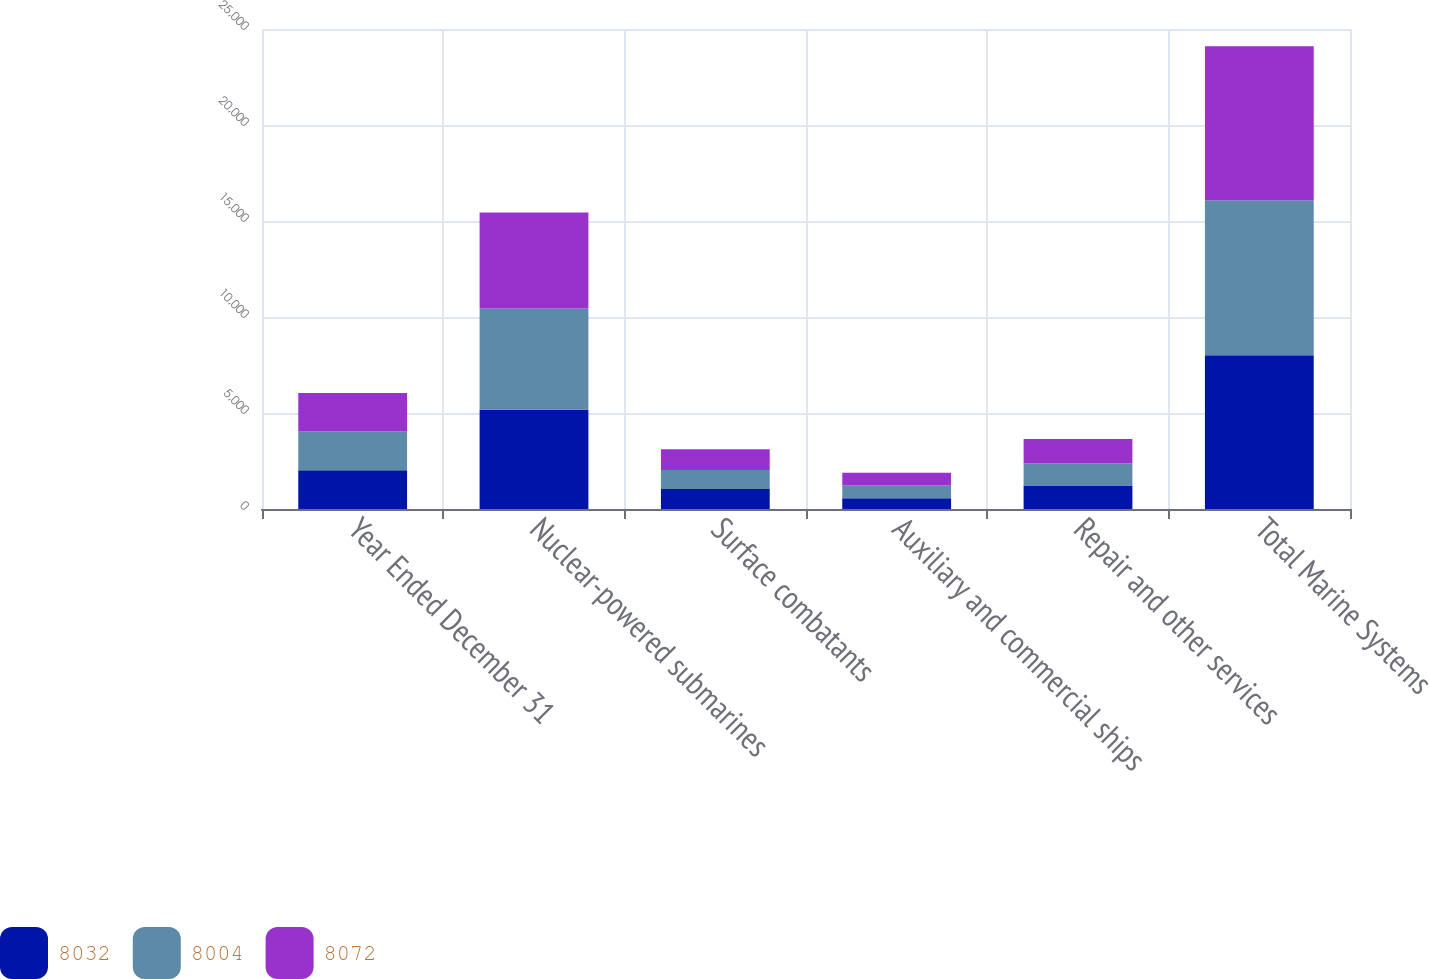<chart> <loc_0><loc_0><loc_500><loc_500><stacked_bar_chart><ecel><fcel>Year Ended December 31<fcel>Nuclear-powered submarines<fcel>Surface combatants<fcel>Auxiliary and commercial ships<fcel>Repair and other services<fcel>Total Marine Systems<nl><fcel>8032<fcel>2017<fcel>5175<fcel>1043<fcel>564<fcel>1222<fcel>8004<nl><fcel>8004<fcel>2016<fcel>5264<fcel>994<fcel>654<fcel>1160<fcel>8072<nl><fcel>8072<fcel>2015<fcel>5010<fcel>1081<fcel>672<fcel>1269<fcel>8032<nl></chart> 